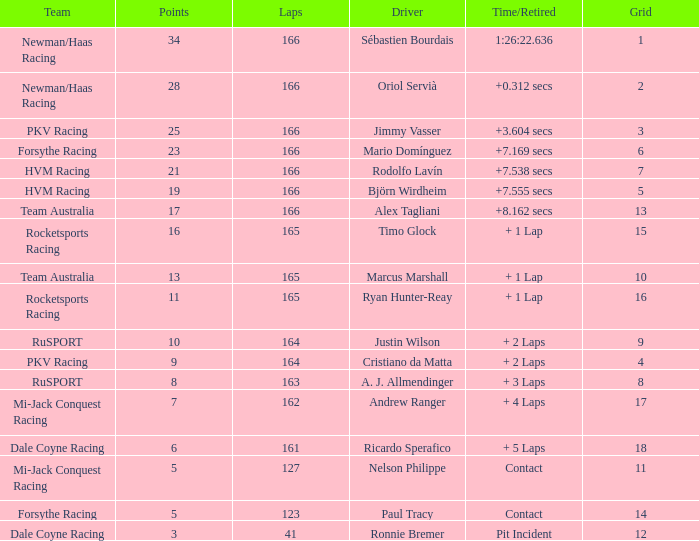What is the biggest points when the grid is less than 13 and the time/retired is +7.538 secs? 21.0. 